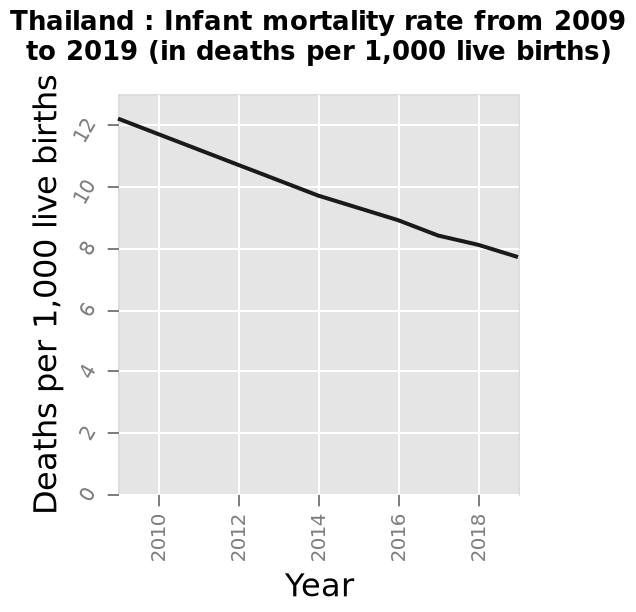<image>
What is the range on the y-axis of the diagram?  The range on the y-axis of the diagram is from 0 to 12, marked as "Deaths per 1,000 live births". 